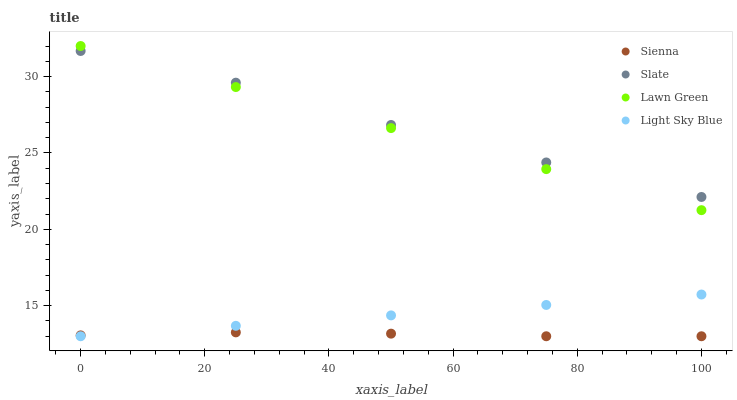Does Sienna have the minimum area under the curve?
Answer yes or no. Yes. Does Slate have the maximum area under the curve?
Answer yes or no. Yes. Does Lawn Green have the minimum area under the curve?
Answer yes or no. No. Does Lawn Green have the maximum area under the curve?
Answer yes or no. No. Is Light Sky Blue the smoothest?
Answer yes or no. Yes. Is Slate the roughest?
Answer yes or no. Yes. Is Lawn Green the smoothest?
Answer yes or no. No. Is Lawn Green the roughest?
Answer yes or no. No. Does Sienna have the lowest value?
Answer yes or no. Yes. Does Lawn Green have the lowest value?
Answer yes or no. No. Does Lawn Green have the highest value?
Answer yes or no. Yes. Does Slate have the highest value?
Answer yes or no. No. Is Light Sky Blue less than Slate?
Answer yes or no. Yes. Is Lawn Green greater than Sienna?
Answer yes or no. Yes. Does Lawn Green intersect Slate?
Answer yes or no. Yes. Is Lawn Green less than Slate?
Answer yes or no. No. Is Lawn Green greater than Slate?
Answer yes or no. No. Does Light Sky Blue intersect Slate?
Answer yes or no. No. 